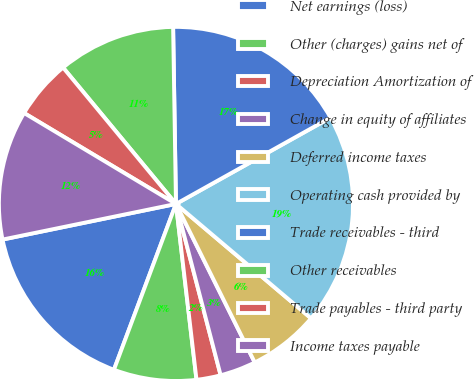<chart> <loc_0><loc_0><loc_500><loc_500><pie_chart><fcel>Net earnings (loss)<fcel>Other (charges) gains net of<fcel>Depreciation Amortization of<fcel>Change in equity of affiliates<fcel>Deferred income taxes<fcel>Operating cash provided by<fcel>Trade receivables - third<fcel>Other receivables<fcel>Trade payables - third party<fcel>Income taxes payable<nl><fcel>16.08%<fcel>7.55%<fcel>2.21%<fcel>3.28%<fcel>6.48%<fcel>19.29%<fcel>17.15%<fcel>10.75%<fcel>5.41%<fcel>11.81%<nl></chart> 